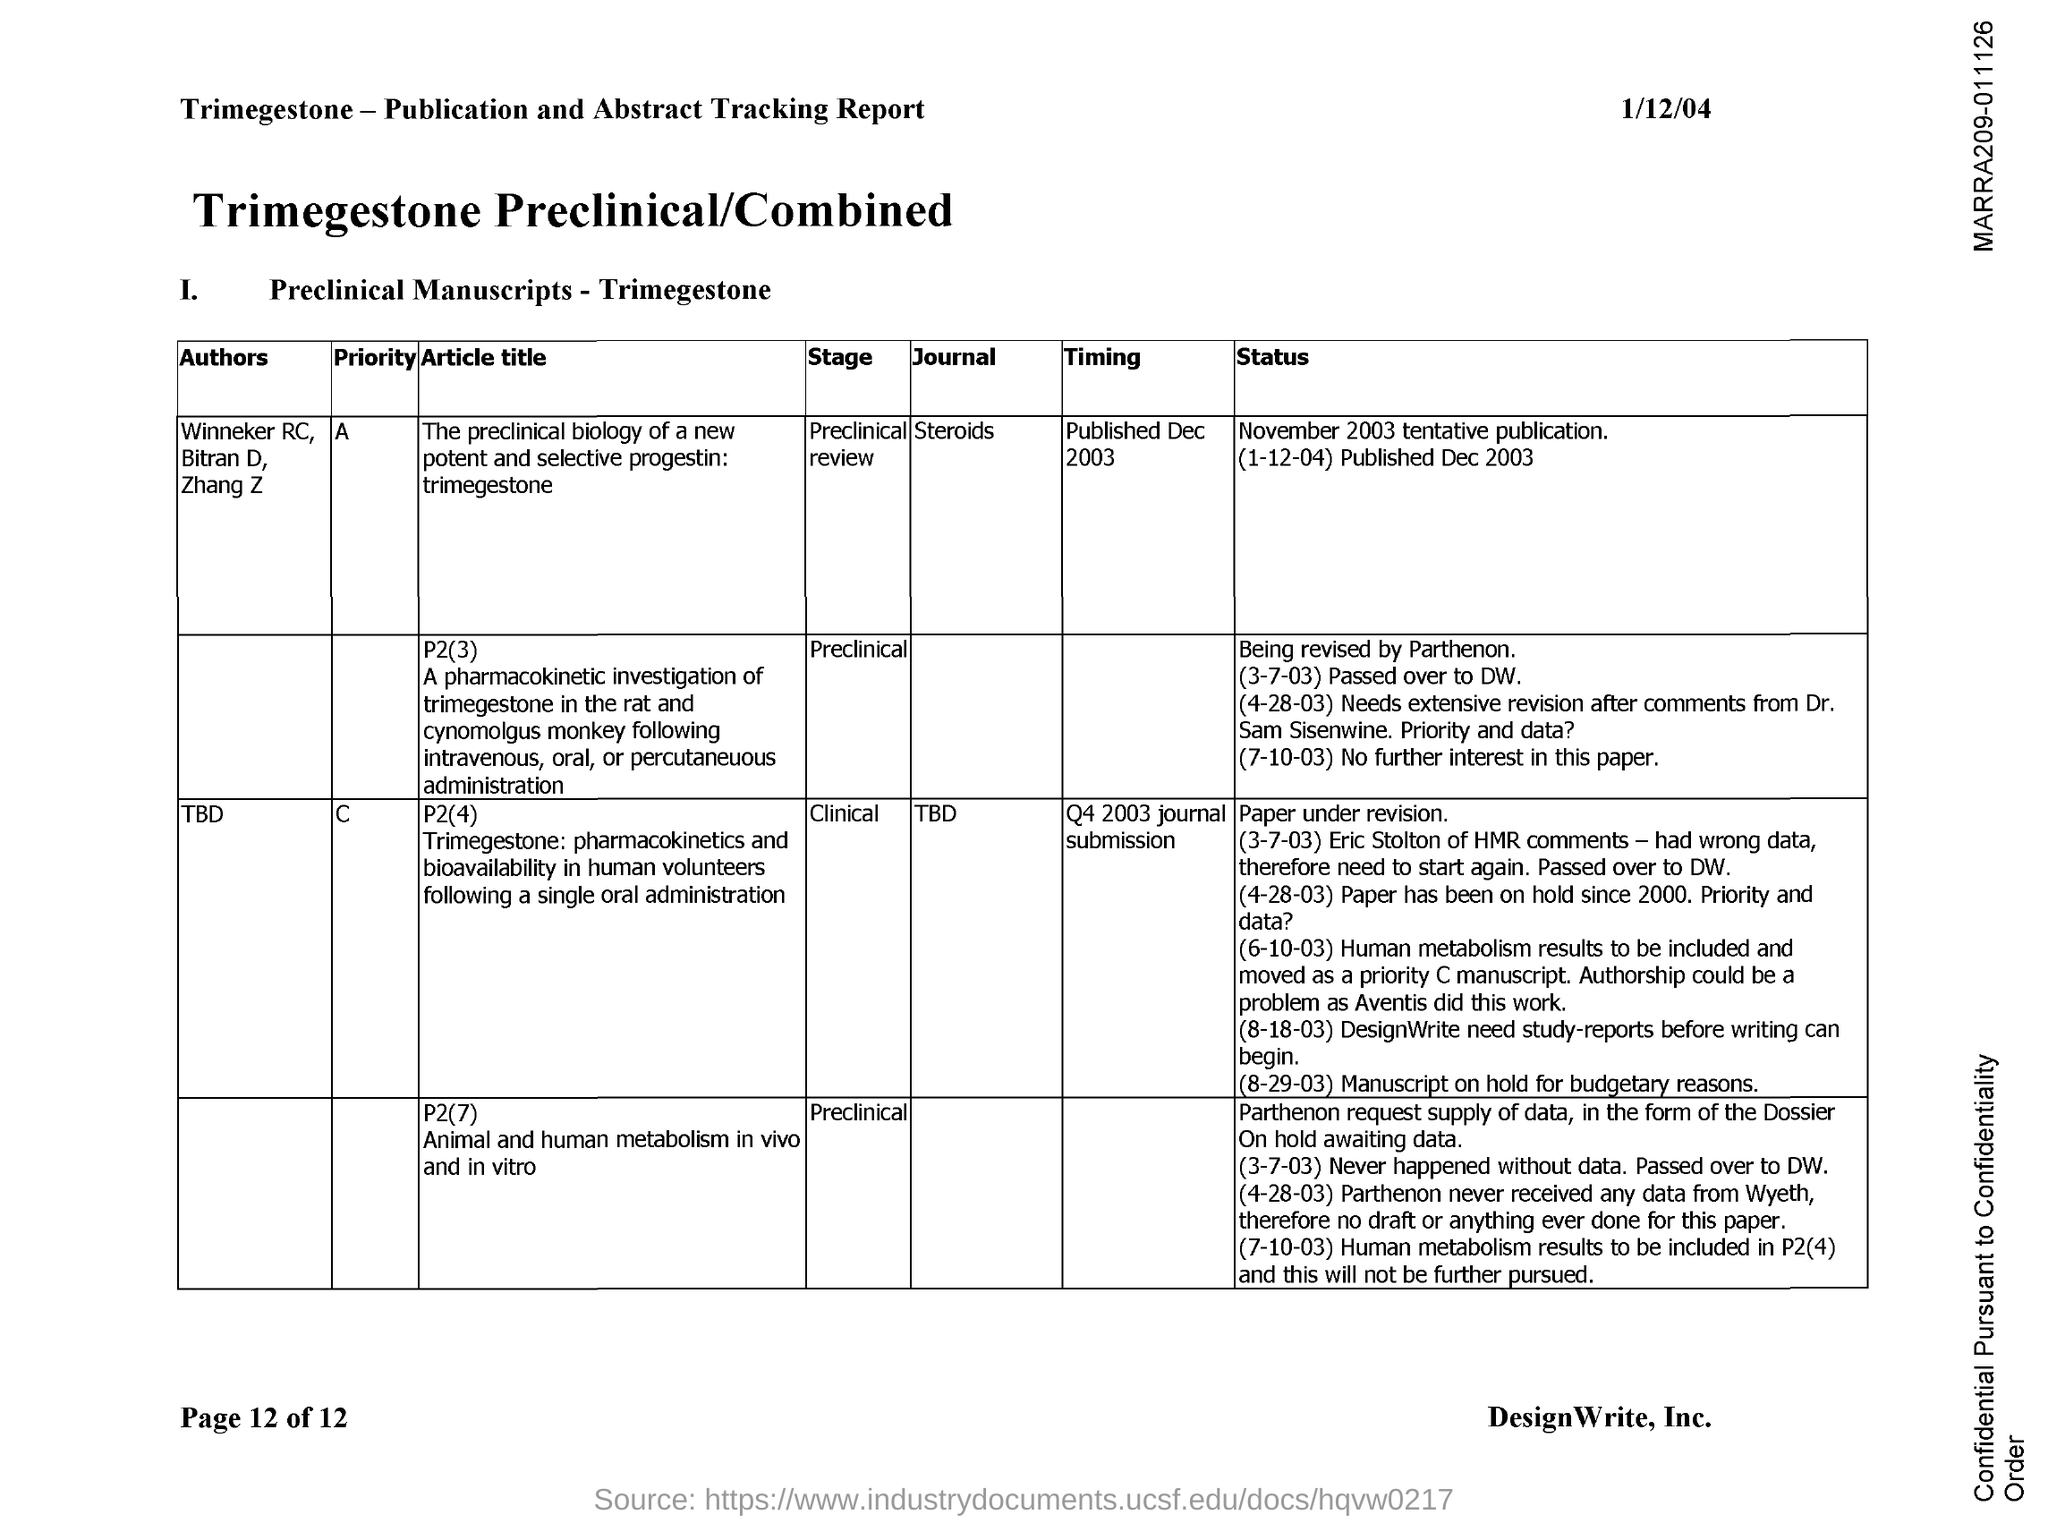What is the "Stage" for the Article "The preclinical biology of a new potentand selective progestin:trimegestone"?
Ensure brevity in your answer.  Preclinical review. Which "Journal" is the Article "The preclinical biology of a new potentand selective progestin:trimegestone" from?
Your answer should be very brief. Steroids. What is the "Timing" for the Article "The preclinical biology of a new potentand selective progestin:trimegestone"?
Your answer should be very brief. Published Dec 2003. 